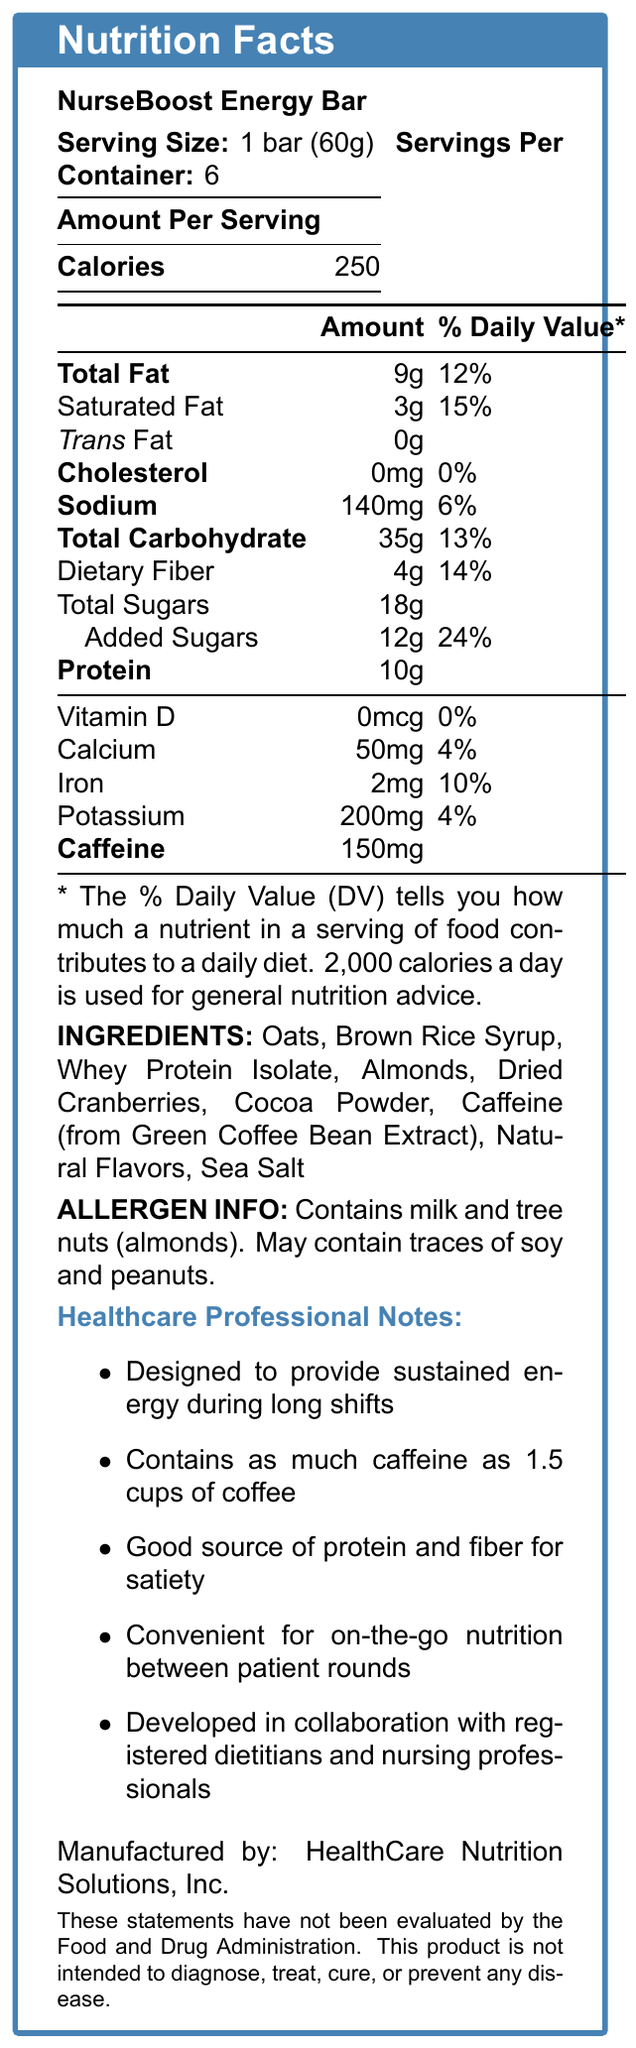what is the serving size of the NurseBoost Energy Bar? The serving size is clearly listed at the top of the Nutrition Facts section as "1 bar (60g)".
Answer: 1 bar (60g) how many calories are there per serving of the NurseBoost Energy Bar? The document states under the Amount Per Serving section that there are 250 calories per serving.
Answer: 250 what is the total amount of fat per serving? In the table under the Amount Per Serving section, Total Fat is listed as 9g.
Answer: 9g how much caffeine does one NurseBoost Energy Bar contain? The document indicates that each bar contains 150mg of caffeine in the nutrient list.
Answer: 150mg what is the protein content per serving in the NurseBoost Energy Bar? Under the nutrient table, Protein is listed with a quantity of 10g.
Answer: 10g how many servings are in one container? A. 4 B. 6 C. 8 D. 12 The document states that there are 6 servings per container, listed at the top with the serving size information.
Answer: B how much dietary fiber does one serving of NurseBoost Energy Bar provide? The nutrient table lists Dietary Fiber as 4g per serving.
Answer: 4g what are the potential allergens in the NurseBoost Energy Bar? A. Soy and peanuts B. Milk and tree nuts C. Wheat and shellfish D. Eggs and fish The allergen information section specifies that the bar contains milk and tree nuts (almonds).
Answer: B does the NurseBoost Energy Bar contain added sugars? The document lists added sugars as 12g, 24% daily value in the nutrient table.
Answer: Yes how much sodium is in one serving of NurseBoost Energy Bar? According to the nutrient table, one serving contains 140mg of sodium.
Answer: 140mg what are the main ingredients in the NurseBoost Energy Bar? The ingredients list provided in the document includes all these items.
Answer: Oats, Brown Rice Syrup, Whey Protein Isolate, Almonds, Dried Cranberries, Cocoa Powder, Caffeine (from Green Coffee Bean Extract), Natural Flavors, Sea Salt how can NurseBoost Energy Bar's caffeine content be described in terms of coffee? The healthcare professional notes mention that the bar contains the same amount of caffeine as 1.5 cups of coffee.
Answer: Contains as much caffeine as 1.5 cups of coffee does the NurseBoost Energy Bar contain any trans fat? Under the nutrient table, Trans Fat is listed as 0g.
Answer: No summarize the main idea of the NurseBoost Energy Bar's Nutrition Facts Label. The document summarizes the nutritional content and purpose of the NurseBoost Energy Bar, emphasizing its energy-boosting properties and convenience for healthcare professionals.
Answer: The NurseBoost Energy Bar is designed for healthcare professionals, offering 250 calories per serving with 9g total fat, 10g protein, and 150mg of caffeine. It aims to provide sustained energy, contains dietary fiber, and has noted allergens including milk and tree nuts. Additional healthcare professional notes emphasize its design for long shifts and convenience. who is the manufacturer of the NurseBoost Energy Bar? The manufacturer is listed at the bottom of the document.
Answer: HealthCare Nutrition Solutions, Inc. is the NurseBoost Energy Bar intended to diagnose, treat, cure, or prevent any disease? The disclaimer at the bottom states that the product is not intended to diagnose, treat, cure, or prevent any disease.
Answer: No how many calories are obtained from protein per serving in the NurseBoost Energy Bar? The document does not provide the specific calorie breakdown for protein, only the total calories and the amount of protein in grams.
Answer: Cannot be determined what percentage of the daily value of iron does one serving provide? The iron content is listed as 2mg, with a daily value percentage of 10%.
Answer: 10% 